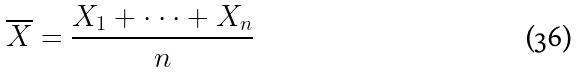Convert formula to latex. <formula><loc_0><loc_0><loc_500><loc_500>\overline { X } = \frac { X _ { 1 } + \cdot \cdot \cdot + X _ { n } } { n }</formula> 